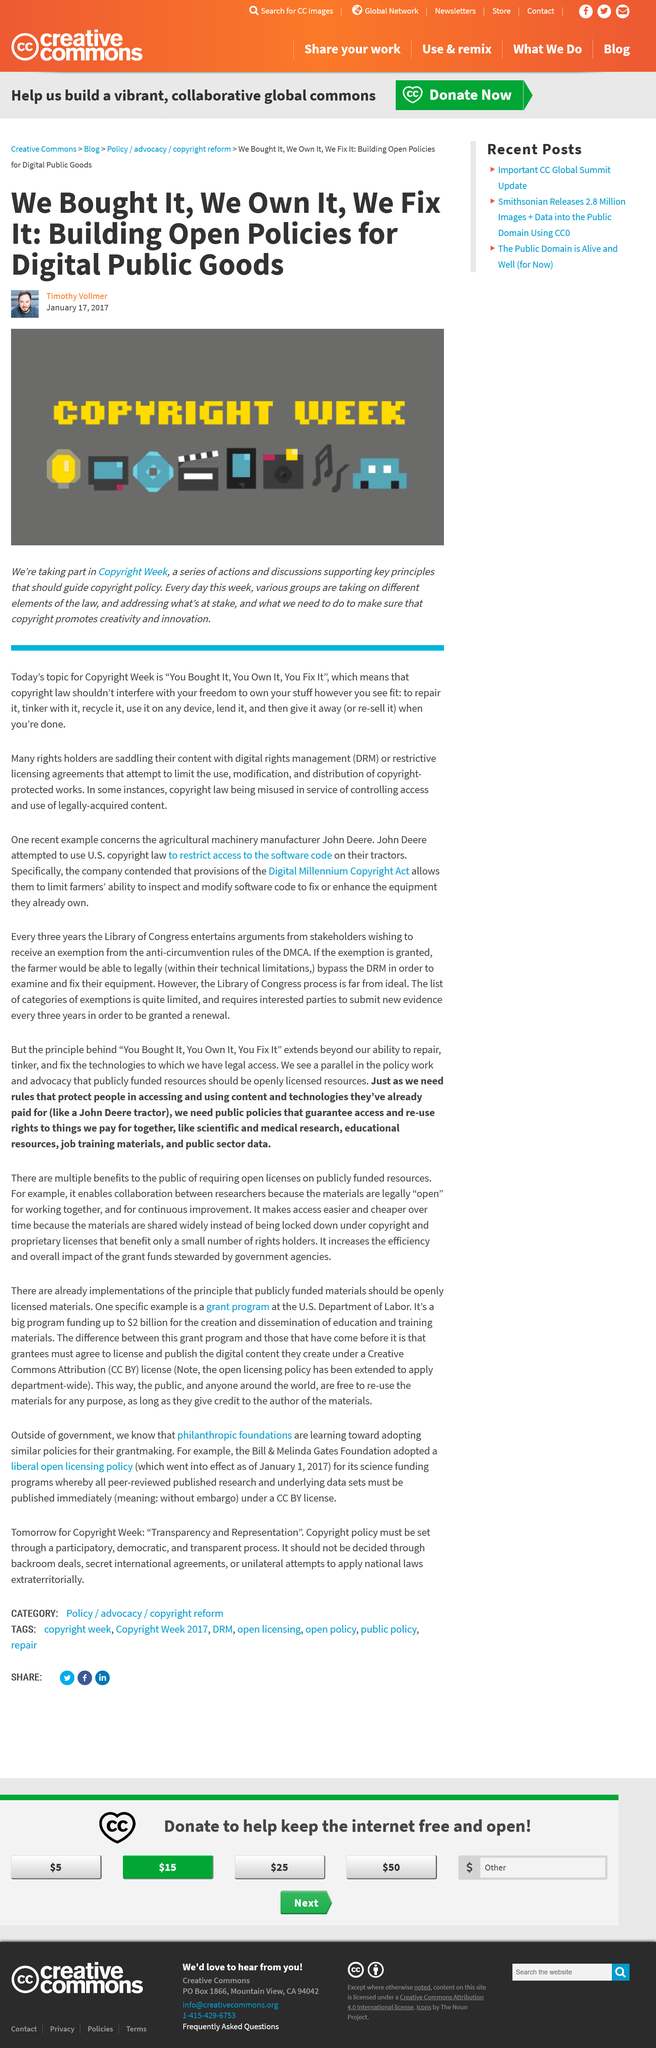Specify some key components in this picture. It is reported that Timothy Vollmer wrote the article about Copyright Week. The person in the photo is named Timothy Vollmer. The article was published on 17th January 2017. 